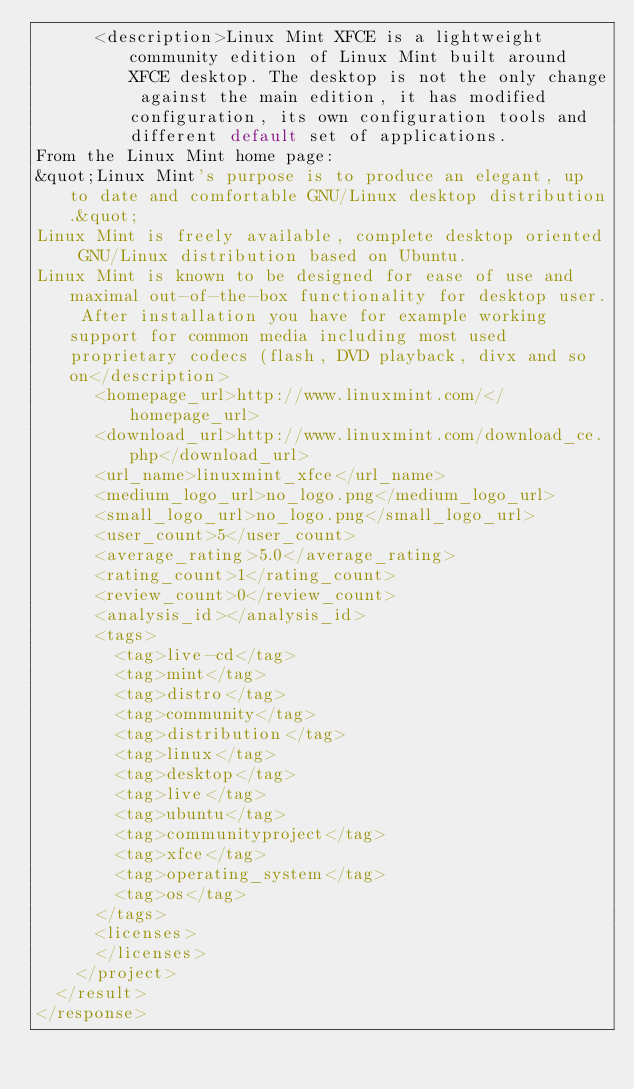Convert code to text. <code><loc_0><loc_0><loc_500><loc_500><_XML_>      <description>Linux Mint XFCE is a lightweight community edition of Linux Mint built around XFCE desktop. The desktop is not the only change against the main edition, it has modified configuration, its own configuration tools and different default set of applications.
From the Linux Mint home page:
&quot;Linux Mint's purpose is to produce an elegant, up to date and comfortable GNU/Linux desktop distribution.&quot;
Linux Mint is freely available, complete desktop oriented GNU/Linux distribution based on Ubuntu. 
Linux Mint is known to be designed for ease of use and maximal out-of-the-box functionality for desktop user. After installation you have for example working support for common media including most used proprietary codecs (flash, DVD playback, divx and so on</description>
      <homepage_url>http://www.linuxmint.com/</homepage_url>
      <download_url>http://www.linuxmint.com/download_ce.php</download_url>
      <url_name>linuxmint_xfce</url_name>
      <medium_logo_url>no_logo.png</medium_logo_url>
      <small_logo_url>no_logo.png</small_logo_url>
      <user_count>5</user_count>
      <average_rating>5.0</average_rating>
      <rating_count>1</rating_count>
      <review_count>0</review_count>
      <analysis_id></analysis_id>
      <tags>
        <tag>live-cd</tag>
        <tag>mint</tag>
        <tag>distro</tag>
        <tag>community</tag>
        <tag>distribution</tag>
        <tag>linux</tag>
        <tag>desktop</tag>
        <tag>live</tag>
        <tag>ubuntu</tag>
        <tag>communityproject</tag>
        <tag>xfce</tag>
        <tag>operating_system</tag>
        <tag>os</tag>
      </tags>
      <licenses>
      </licenses>
    </project>
  </result>
</response>
</code> 